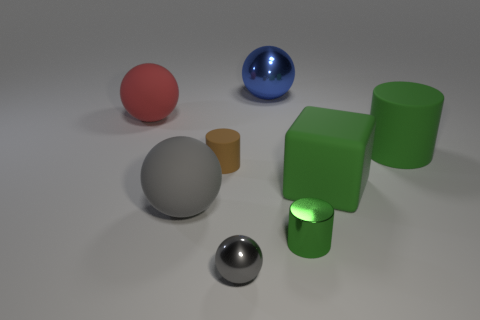Are there any other things that are the same material as the small gray ball?
Make the answer very short. Yes. What number of big objects are right of the metallic object that is left of the metal ball that is behind the large gray object?
Offer a very short reply. 3. The matte block has what size?
Make the answer very short. Large. Is the color of the big cylinder the same as the rubber block?
Your response must be concise. Yes. There is a rubber sphere that is right of the red matte thing; what is its size?
Your response must be concise. Large. There is a ball in front of the shiny cylinder; is its color the same as the small cylinder on the left side of the tiny green thing?
Provide a short and direct response. No. What number of other things are there of the same shape as the tiny green metallic thing?
Offer a terse response. 2. Are there an equal number of small gray objects in front of the brown thing and large matte balls in front of the green block?
Your answer should be compact. Yes. Is the green cylinder on the right side of the large block made of the same material as the thing behind the red matte object?
Make the answer very short. No. What number of other objects are there of the same size as the red rubber thing?
Offer a very short reply. 4. 